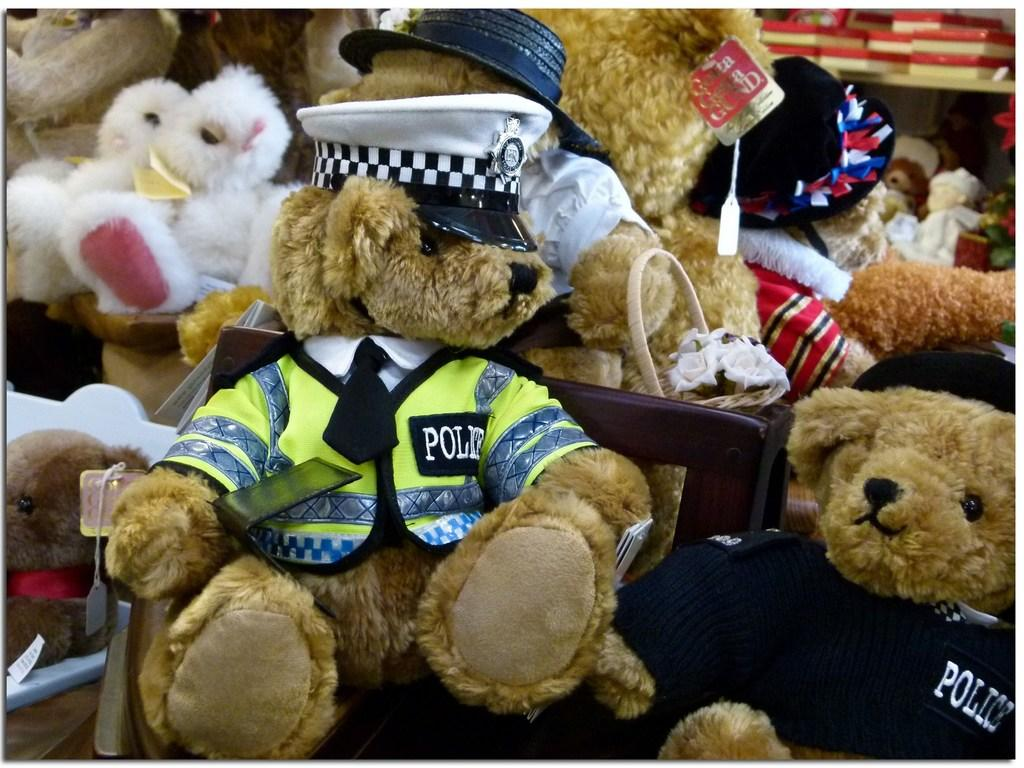What type of objects can be seen in the image? There are soft toys in the image. Where are the boxes located in the image? The boxes are in the shelf in the image. What is placed on the soft toys? There are caps on the toys. What type of oil can be seen dripping from the toys in the image? There is no oil present in the image; the toys have caps on them. 